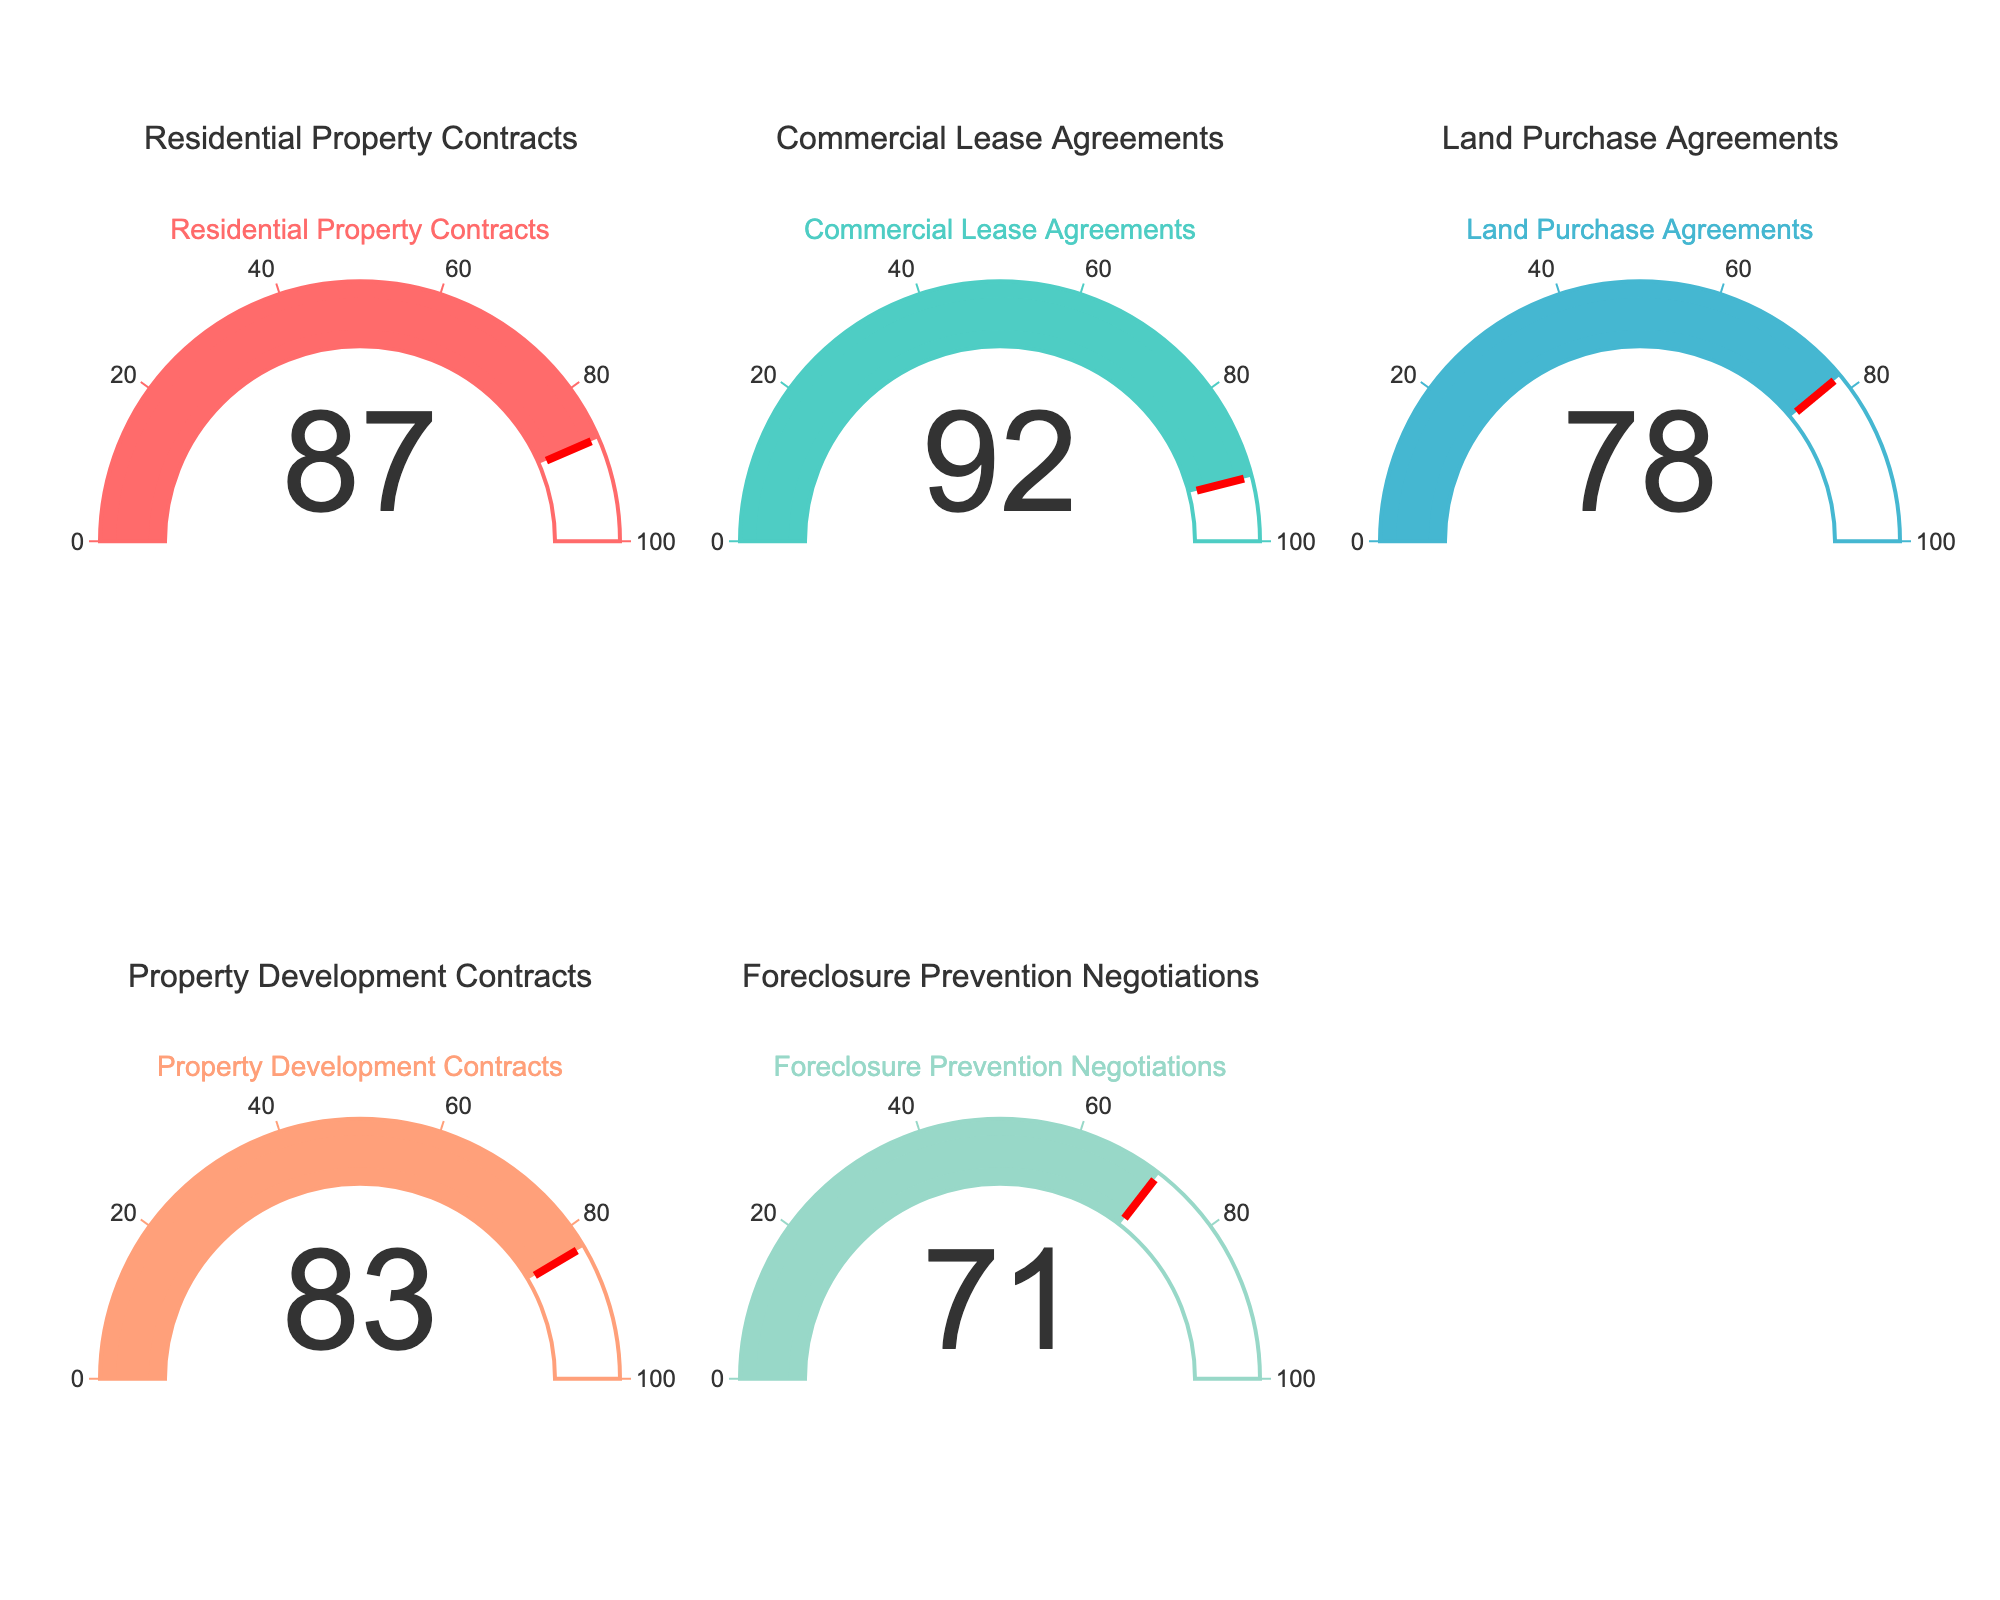What category has the highest percentage of successful contract negotiations? By examining the gauge chart, the category with the highest percentage is the one whose needle points to the highest value. Here, "Commercial Lease Agreements" has the highest value at 92%.
Answer: Commercial Lease Agreements Which category has the lowest percentage? Look at the category with the lowest gauge value. "Foreclosure Prevention Negotiations" has the lowest percentage on the chart at 71%.
Answer: Foreclosure Prevention Negotiations What is the average percentage of successful contract negotiations across all categories? Add up all the percentages and divide by the number of categories: (87 + 92 + 78 + 83 + 71) / 5 = 411 / 5 = 82.2.
Answer: 82.2 How much higher is the percentage of successful contract negotiations for Commercial Lease Agreements compared to Foreclosure Prevention Negotiations? Subtract the percentage of Foreclosure Prevention Negotiations from Commercial Lease Agreements: 92 - 71 = 21.
Answer: 21 Do any categories have a success rate above 90%? Check which gauges show values above 90%. Only "Commercial Lease Agreements" has a success rate above 90% with 92%.
Answer: Yes, Commercial Lease Agreements Which categories have a success rate above and below the average percentage? The average percentage is 82.2. Categories above this average are "Residential Property Contracts" (87), "Commercial Lease Agreements" (92), and "Property Development Contracts" (83). Categories below are "Land Purchase Agreements" (78) and "Foreclosure Prevention Negotiations" (71).
Answer: Above: Residential Property Contracts, Commercial Lease Agreements, Property Development Contracts; Below: Land Purchase Agreements, Foreclosure Prevention Negotiations What is the difference in success rates between the highest and lowest categories? Subtract the lowest percentage from the highest percentage: 92 - 71 = 21.
Answer: 21 How many categories have a success rate between 80% and 90%? Identify the categories where the gauge values fall within the range of 80 to 90. "Residential Property Contracts" and "Property Development Contracts" fall in this range.
Answer: 2 Is the success rate for Land Purchase Agreements closer to Residential Property Contracts or Foreclosure Prevention Negotiations? Compare the difference between Land Purchase Agreements (78) with Residential Property Contracts (87) and Foreclosure Prevention Negotiations (71). Differences are 87-78 = 9 and 78-71 = 7; thus, it is closer to Foreclosure Prevention Negotiations.
Answer: Foreclosure Prevention Negotiations 